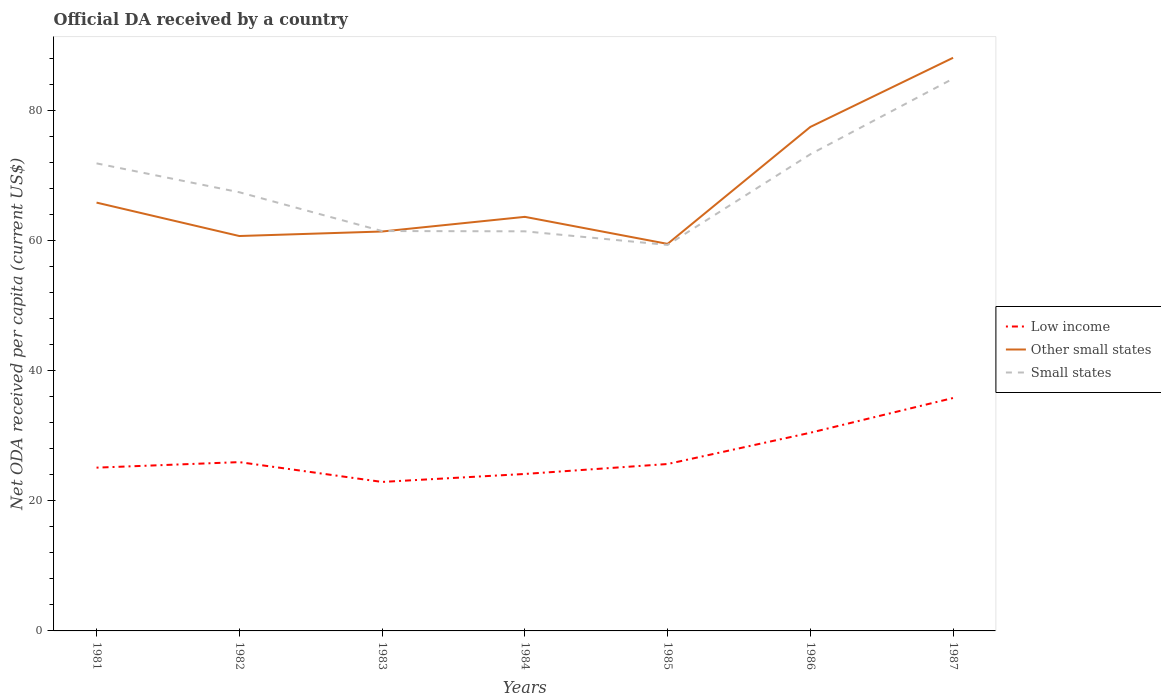Does the line corresponding to Low income intersect with the line corresponding to Other small states?
Your answer should be compact. No. Across all years, what is the maximum ODA received in in Small states?
Provide a succinct answer. 59.34. In which year was the ODA received in in Other small states maximum?
Give a very brief answer. 1985. What is the total ODA received in in Other small states in the graph?
Make the answer very short. -2.95. What is the difference between the highest and the second highest ODA received in in Other small states?
Keep it short and to the point. 28.61. What is the difference between the highest and the lowest ODA received in in Other small states?
Your response must be concise. 2. How many years are there in the graph?
Your response must be concise. 7. Are the values on the major ticks of Y-axis written in scientific E-notation?
Provide a short and direct response. No. How are the legend labels stacked?
Ensure brevity in your answer.  Vertical. What is the title of the graph?
Make the answer very short. Official DA received by a country. What is the label or title of the X-axis?
Provide a short and direct response. Years. What is the label or title of the Y-axis?
Your answer should be very brief. Net ODA received per capita (current US$). What is the Net ODA received per capita (current US$) of Low income in 1981?
Provide a short and direct response. 25.1. What is the Net ODA received per capita (current US$) in Other small states in 1981?
Make the answer very short. 65.85. What is the Net ODA received per capita (current US$) of Small states in 1981?
Your answer should be very brief. 71.88. What is the Net ODA received per capita (current US$) in Low income in 1982?
Offer a very short reply. 25.95. What is the Net ODA received per capita (current US$) of Other small states in 1982?
Provide a short and direct response. 60.71. What is the Net ODA received per capita (current US$) of Small states in 1982?
Make the answer very short. 67.44. What is the Net ODA received per capita (current US$) of Low income in 1983?
Offer a terse response. 22.9. What is the Net ODA received per capita (current US$) of Other small states in 1983?
Give a very brief answer. 61.4. What is the Net ODA received per capita (current US$) in Small states in 1983?
Your answer should be very brief. 61.48. What is the Net ODA received per capita (current US$) in Low income in 1984?
Provide a succinct answer. 24.13. What is the Net ODA received per capita (current US$) of Other small states in 1984?
Provide a short and direct response. 63.66. What is the Net ODA received per capita (current US$) of Small states in 1984?
Give a very brief answer. 61.43. What is the Net ODA received per capita (current US$) in Low income in 1985?
Keep it short and to the point. 25.66. What is the Net ODA received per capita (current US$) in Other small states in 1985?
Provide a succinct answer. 59.5. What is the Net ODA received per capita (current US$) in Small states in 1985?
Provide a short and direct response. 59.34. What is the Net ODA received per capita (current US$) in Low income in 1986?
Provide a succinct answer. 30.47. What is the Net ODA received per capita (current US$) in Other small states in 1986?
Your answer should be very brief. 77.48. What is the Net ODA received per capita (current US$) in Small states in 1986?
Provide a succinct answer. 73.28. What is the Net ODA received per capita (current US$) in Low income in 1987?
Offer a very short reply. 35.81. What is the Net ODA received per capita (current US$) in Other small states in 1987?
Offer a very short reply. 88.11. What is the Net ODA received per capita (current US$) in Small states in 1987?
Give a very brief answer. 84.9. Across all years, what is the maximum Net ODA received per capita (current US$) of Low income?
Keep it short and to the point. 35.81. Across all years, what is the maximum Net ODA received per capita (current US$) in Other small states?
Make the answer very short. 88.11. Across all years, what is the maximum Net ODA received per capita (current US$) of Small states?
Your response must be concise. 84.9. Across all years, what is the minimum Net ODA received per capita (current US$) in Low income?
Your response must be concise. 22.9. Across all years, what is the minimum Net ODA received per capita (current US$) in Other small states?
Your answer should be compact. 59.5. Across all years, what is the minimum Net ODA received per capita (current US$) in Small states?
Your answer should be compact. 59.34. What is the total Net ODA received per capita (current US$) in Low income in the graph?
Your answer should be very brief. 190.02. What is the total Net ODA received per capita (current US$) in Other small states in the graph?
Make the answer very short. 476.71. What is the total Net ODA received per capita (current US$) of Small states in the graph?
Give a very brief answer. 479.75. What is the difference between the Net ODA received per capita (current US$) of Low income in 1981 and that in 1982?
Your answer should be compact. -0.85. What is the difference between the Net ODA received per capita (current US$) of Other small states in 1981 and that in 1982?
Keep it short and to the point. 5.14. What is the difference between the Net ODA received per capita (current US$) in Small states in 1981 and that in 1982?
Ensure brevity in your answer.  4.44. What is the difference between the Net ODA received per capita (current US$) in Low income in 1981 and that in 1983?
Make the answer very short. 2.2. What is the difference between the Net ODA received per capita (current US$) of Other small states in 1981 and that in 1983?
Make the answer very short. 4.44. What is the difference between the Net ODA received per capita (current US$) in Small states in 1981 and that in 1983?
Offer a very short reply. 10.4. What is the difference between the Net ODA received per capita (current US$) of Low income in 1981 and that in 1984?
Your answer should be very brief. 0.97. What is the difference between the Net ODA received per capita (current US$) in Other small states in 1981 and that in 1984?
Keep it short and to the point. 2.19. What is the difference between the Net ODA received per capita (current US$) of Small states in 1981 and that in 1984?
Your response must be concise. 10.45. What is the difference between the Net ODA received per capita (current US$) in Low income in 1981 and that in 1985?
Provide a succinct answer. -0.56. What is the difference between the Net ODA received per capita (current US$) in Other small states in 1981 and that in 1985?
Give a very brief answer. 6.35. What is the difference between the Net ODA received per capita (current US$) in Small states in 1981 and that in 1985?
Offer a very short reply. 12.54. What is the difference between the Net ODA received per capita (current US$) in Low income in 1981 and that in 1986?
Your answer should be very brief. -5.37. What is the difference between the Net ODA received per capita (current US$) of Other small states in 1981 and that in 1986?
Provide a short and direct response. -11.63. What is the difference between the Net ODA received per capita (current US$) of Small states in 1981 and that in 1986?
Provide a succinct answer. -1.4. What is the difference between the Net ODA received per capita (current US$) of Low income in 1981 and that in 1987?
Offer a terse response. -10.71. What is the difference between the Net ODA received per capita (current US$) of Other small states in 1981 and that in 1987?
Offer a terse response. -22.26. What is the difference between the Net ODA received per capita (current US$) of Small states in 1981 and that in 1987?
Ensure brevity in your answer.  -13.02. What is the difference between the Net ODA received per capita (current US$) of Low income in 1982 and that in 1983?
Offer a terse response. 3.05. What is the difference between the Net ODA received per capita (current US$) of Other small states in 1982 and that in 1983?
Offer a very short reply. -0.69. What is the difference between the Net ODA received per capita (current US$) in Small states in 1982 and that in 1983?
Your response must be concise. 5.96. What is the difference between the Net ODA received per capita (current US$) in Low income in 1982 and that in 1984?
Your answer should be very brief. 1.82. What is the difference between the Net ODA received per capita (current US$) of Other small states in 1982 and that in 1984?
Keep it short and to the point. -2.95. What is the difference between the Net ODA received per capita (current US$) in Small states in 1982 and that in 1984?
Your answer should be very brief. 6.01. What is the difference between the Net ODA received per capita (current US$) in Low income in 1982 and that in 1985?
Give a very brief answer. 0.29. What is the difference between the Net ODA received per capita (current US$) in Other small states in 1982 and that in 1985?
Provide a succinct answer. 1.21. What is the difference between the Net ODA received per capita (current US$) in Small states in 1982 and that in 1985?
Give a very brief answer. 8.1. What is the difference between the Net ODA received per capita (current US$) in Low income in 1982 and that in 1986?
Offer a terse response. -4.52. What is the difference between the Net ODA received per capita (current US$) of Other small states in 1982 and that in 1986?
Provide a succinct answer. -16.77. What is the difference between the Net ODA received per capita (current US$) in Small states in 1982 and that in 1986?
Make the answer very short. -5.84. What is the difference between the Net ODA received per capita (current US$) of Low income in 1982 and that in 1987?
Your response must be concise. -9.86. What is the difference between the Net ODA received per capita (current US$) of Other small states in 1982 and that in 1987?
Offer a very short reply. -27.4. What is the difference between the Net ODA received per capita (current US$) of Small states in 1982 and that in 1987?
Give a very brief answer. -17.46. What is the difference between the Net ODA received per capita (current US$) of Low income in 1983 and that in 1984?
Ensure brevity in your answer.  -1.23. What is the difference between the Net ODA received per capita (current US$) of Other small states in 1983 and that in 1984?
Ensure brevity in your answer.  -2.25. What is the difference between the Net ODA received per capita (current US$) of Small states in 1983 and that in 1984?
Your answer should be very brief. 0.04. What is the difference between the Net ODA received per capita (current US$) in Low income in 1983 and that in 1985?
Make the answer very short. -2.75. What is the difference between the Net ODA received per capita (current US$) in Other small states in 1983 and that in 1985?
Your answer should be compact. 1.9. What is the difference between the Net ODA received per capita (current US$) in Small states in 1983 and that in 1985?
Provide a short and direct response. 2.13. What is the difference between the Net ODA received per capita (current US$) in Low income in 1983 and that in 1986?
Provide a succinct answer. -7.56. What is the difference between the Net ODA received per capita (current US$) in Other small states in 1983 and that in 1986?
Your answer should be very brief. -16.07. What is the difference between the Net ODA received per capita (current US$) of Small states in 1983 and that in 1986?
Your response must be concise. -11.8. What is the difference between the Net ODA received per capita (current US$) of Low income in 1983 and that in 1987?
Give a very brief answer. -12.9. What is the difference between the Net ODA received per capita (current US$) in Other small states in 1983 and that in 1987?
Make the answer very short. -26.71. What is the difference between the Net ODA received per capita (current US$) in Small states in 1983 and that in 1987?
Give a very brief answer. -23.43. What is the difference between the Net ODA received per capita (current US$) in Low income in 1984 and that in 1985?
Give a very brief answer. -1.53. What is the difference between the Net ODA received per capita (current US$) of Other small states in 1984 and that in 1985?
Ensure brevity in your answer.  4.16. What is the difference between the Net ODA received per capita (current US$) in Small states in 1984 and that in 1985?
Your answer should be very brief. 2.09. What is the difference between the Net ODA received per capita (current US$) in Low income in 1984 and that in 1986?
Keep it short and to the point. -6.34. What is the difference between the Net ODA received per capita (current US$) of Other small states in 1984 and that in 1986?
Your answer should be compact. -13.82. What is the difference between the Net ODA received per capita (current US$) of Small states in 1984 and that in 1986?
Give a very brief answer. -11.85. What is the difference between the Net ODA received per capita (current US$) of Low income in 1984 and that in 1987?
Ensure brevity in your answer.  -11.68. What is the difference between the Net ODA received per capita (current US$) of Other small states in 1984 and that in 1987?
Your answer should be compact. -24.45. What is the difference between the Net ODA received per capita (current US$) of Small states in 1984 and that in 1987?
Your response must be concise. -23.47. What is the difference between the Net ODA received per capita (current US$) of Low income in 1985 and that in 1986?
Your answer should be very brief. -4.81. What is the difference between the Net ODA received per capita (current US$) of Other small states in 1985 and that in 1986?
Keep it short and to the point. -17.98. What is the difference between the Net ODA received per capita (current US$) of Small states in 1985 and that in 1986?
Keep it short and to the point. -13.94. What is the difference between the Net ODA received per capita (current US$) in Low income in 1985 and that in 1987?
Give a very brief answer. -10.15. What is the difference between the Net ODA received per capita (current US$) in Other small states in 1985 and that in 1987?
Your answer should be very brief. -28.61. What is the difference between the Net ODA received per capita (current US$) in Small states in 1985 and that in 1987?
Offer a very short reply. -25.56. What is the difference between the Net ODA received per capita (current US$) of Low income in 1986 and that in 1987?
Ensure brevity in your answer.  -5.34. What is the difference between the Net ODA received per capita (current US$) in Other small states in 1986 and that in 1987?
Your response must be concise. -10.63. What is the difference between the Net ODA received per capita (current US$) of Small states in 1986 and that in 1987?
Your response must be concise. -11.62. What is the difference between the Net ODA received per capita (current US$) in Low income in 1981 and the Net ODA received per capita (current US$) in Other small states in 1982?
Your response must be concise. -35.61. What is the difference between the Net ODA received per capita (current US$) of Low income in 1981 and the Net ODA received per capita (current US$) of Small states in 1982?
Provide a short and direct response. -42.34. What is the difference between the Net ODA received per capita (current US$) in Other small states in 1981 and the Net ODA received per capita (current US$) in Small states in 1982?
Keep it short and to the point. -1.59. What is the difference between the Net ODA received per capita (current US$) of Low income in 1981 and the Net ODA received per capita (current US$) of Other small states in 1983?
Your answer should be compact. -36.3. What is the difference between the Net ODA received per capita (current US$) of Low income in 1981 and the Net ODA received per capita (current US$) of Small states in 1983?
Your answer should be compact. -36.37. What is the difference between the Net ODA received per capita (current US$) in Other small states in 1981 and the Net ODA received per capita (current US$) in Small states in 1983?
Ensure brevity in your answer.  4.37. What is the difference between the Net ODA received per capita (current US$) in Low income in 1981 and the Net ODA received per capita (current US$) in Other small states in 1984?
Offer a very short reply. -38.56. What is the difference between the Net ODA received per capita (current US$) of Low income in 1981 and the Net ODA received per capita (current US$) of Small states in 1984?
Offer a very short reply. -36.33. What is the difference between the Net ODA received per capita (current US$) of Other small states in 1981 and the Net ODA received per capita (current US$) of Small states in 1984?
Your answer should be very brief. 4.41. What is the difference between the Net ODA received per capita (current US$) in Low income in 1981 and the Net ODA received per capita (current US$) in Other small states in 1985?
Give a very brief answer. -34.4. What is the difference between the Net ODA received per capita (current US$) of Low income in 1981 and the Net ODA received per capita (current US$) of Small states in 1985?
Make the answer very short. -34.24. What is the difference between the Net ODA received per capita (current US$) in Other small states in 1981 and the Net ODA received per capita (current US$) in Small states in 1985?
Your answer should be very brief. 6.51. What is the difference between the Net ODA received per capita (current US$) in Low income in 1981 and the Net ODA received per capita (current US$) in Other small states in 1986?
Give a very brief answer. -52.38. What is the difference between the Net ODA received per capita (current US$) of Low income in 1981 and the Net ODA received per capita (current US$) of Small states in 1986?
Give a very brief answer. -48.18. What is the difference between the Net ODA received per capita (current US$) in Other small states in 1981 and the Net ODA received per capita (current US$) in Small states in 1986?
Provide a succinct answer. -7.43. What is the difference between the Net ODA received per capita (current US$) in Low income in 1981 and the Net ODA received per capita (current US$) in Other small states in 1987?
Your answer should be very brief. -63.01. What is the difference between the Net ODA received per capita (current US$) in Low income in 1981 and the Net ODA received per capita (current US$) in Small states in 1987?
Your answer should be compact. -59.8. What is the difference between the Net ODA received per capita (current US$) in Other small states in 1981 and the Net ODA received per capita (current US$) in Small states in 1987?
Ensure brevity in your answer.  -19.05. What is the difference between the Net ODA received per capita (current US$) of Low income in 1982 and the Net ODA received per capita (current US$) of Other small states in 1983?
Give a very brief answer. -35.45. What is the difference between the Net ODA received per capita (current US$) in Low income in 1982 and the Net ODA received per capita (current US$) in Small states in 1983?
Offer a terse response. -35.52. What is the difference between the Net ODA received per capita (current US$) in Other small states in 1982 and the Net ODA received per capita (current US$) in Small states in 1983?
Give a very brief answer. -0.77. What is the difference between the Net ODA received per capita (current US$) in Low income in 1982 and the Net ODA received per capita (current US$) in Other small states in 1984?
Keep it short and to the point. -37.71. What is the difference between the Net ODA received per capita (current US$) in Low income in 1982 and the Net ODA received per capita (current US$) in Small states in 1984?
Give a very brief answer. -35.48. What is the difference between the Net ODA received per capita (current US$) of Other small states in 1982 and the Net ODA received per capita (current US$) of Small states in 1984?
Offer a very short reply. -0.72. What is the difference between the Net ODA received per capita (current US$) of Low income in 1982 and the Net ODA received per capita (current US$) of Other small states in 1985?
Your answer should be compact. -33.55. What is the difference between the Net ODA received per capita (current US$) in Low income in 1982 and the Net ODA received per capita (current US$) in Small states in 1985?
Offer a very short reply. -33.39. What is the difference between the Net ODA received per capita (current US$) of Other small states in 1982 and the Net ODA received per capita (current US$) of Small states in 1985?
Ensure brevity in your answer.  1.37. What is the difference between the Net ODA received per capita (current US$) of Low income in 1982 and the Net ODA received per capita (current US$) of Other small states in 1986?
Offer a very short reply. -51.53. What is the difference between the Net ODA received per capita (current US$) of Low income in 1982 and the Net ODA received per capita (current US$) of Small states in 1986?
Make the answer very short. -47.33. What is the difference between the Net ODA received per capita (current US$) in Other small states in 1982 and the Net ODA received per capita (current US$) in Small states in 1986?
Your response must be concise. -12.57. What is the difference between the Net ODA received per capita (current US$) in Low income in 1982 and the Net ODA received per capita (current US$) in Other small states in 1987?
Your answer should be very brief. -62.16. What is the difference between the Net ODA received per capita (current US$) in Low income in 1982 and the Net ODA received per capita (current US$) in Small states in 1987?
Provide a short and direct response. -58.95. What is the difference between the Net ODA received per capita (current US$) in Other small states in 1982 and the Net ODA received per capita (current US$) in Small states in 1987?
Give a very brief answer. -24.19. What is the difference between the Net ODA received per capita (current US$) in Low income in 1983 and the Net ODA received per capita (current US$) in Other small states in 1984?
Make the answer very short. -40.75. What is the difference between the Net ODA received per capita (current US$) of Low income in 1983 and the Net ODA received per capita (current US$) of Small states in 1984?
Offer a terse response. -38.53. What is the difference between the Net ODA received per capita (current US$) of Other small states in 1983 and the Net ODA received per capita (current US$) of Small states in 1984?
Your answer should be very brief. -0.03. What is the difference between the Net ODA received per capita (current US$) in Low income in 1983 and the Net ODA received per capita (current US$) in Other small states in 1985?
Give a very brief answer. -36.6. What is the difference between the Net ODA received per capita (current US$) of Low income in 1983 and the Net ODA received per capita (current US$) of Small states in 1985?
Your response must be concise. -36.44. What is the difference between the Net ODA received per capita (current US$) in Other small states in 1983 and the Net ODA received per capita (current US$) in Small states in 1985?
Your response must be concise. 2.06. What is the difference between the Net ODA received per capita (current US$) of Low income in 1983 and the Net ODA received per capita (current US$) of Other small states in 1986?
Give a very brief answer. -54.58. What is the difference between the Net ODA received per capita (current US$) in Low income in 1983 and the Net ODA received per capita (current US$) in Small states in 1986?
Offer a terse response. -50.37. What is the difference between the Net ODA received per capita (current US$) of Other small states in 1983 and the Net ODA received per capita (current US$) of Small states in 1986?
Ensure brevity in your answer.  -11.87. What is the difference between the Net ODA received per capita (current US$) in Low income in 1983 and the Net ODA received per capita (current US$) in Other small states in 1987?
Provide a succinct answer. -65.21. What is the difference between the Net ODA received per capita (current US$) in Low income in 1983 and the Net ODA received per capita (current US$) in Small states in 1987?
Your answer should be very brief. -62. What is the difference between the Net ODA received per capita (current US$) in Other small states in 1983 and the Net ODA received per capita (current US$) in Small states in 1987?
Make the answer very short. -23.5. What is the difference between the Net ODA received per capita (current US$) in Low income in 1984 and the Net ODA received per capita (current US$) in Other small states in 1985?
Provide a short and direct response. -35.37. What is the difference between the Net ODA received per capita (current US$) in Low income in 1984 and the Net ODA received per capita (current US$) in Small states in 1985?
Your answer should be very brief. -35.21. What is the difference between the Net ODA received per capita (current US$) of Other small states in 1984 and the Net ODA received per capita (current US$) of Small states in 1985?
Provide a succinct answer. 4.32. What is the difference between the Net ODA received per capita (current US$) of Low income in 1984 and the Net ODA received per capita (current US$) of Other small states in 1986?
Offer a terse response. -53.35. What is the difference between the Net ODA received per capita (current US$) in Low income in 1984 and the Net ODA received per capita (current US$) in Small states in 1986?
Offer a terse response. -49.15. What is the difference between the Net ODA received per capita (current US$) in Other small states in 1984 and the Net ODA received per capita (current US$) in Small states in 1986?
Your response must be concise. -9.62. What is the difference between the Net ODA received per capita (current US$) of Low income in 1984 and the Net ODA received per capita (current US$) of Other small states in 1987?
Provide a succinct answer. -63.98. What is the difference between the Net ODA received per capita (current US$) of Low income in 1984 and the Net ODA received per capita (current US$) of Small states in 1987?
Your response must be concise. -60.77. What is the difference between the Net ODA received per capita (current US$) in Other small states in 1984 and the Net ODA received per capita (current US$) in Small states in 1987?
Your response must be concise. -21.24. What is the difference between the Net ODA received per capita (current US$) of Low income in 1985 and the Net ODA received per capita (current US$) of Other small states in 1986?
Your response must be concise. -51.82. What is the difference between the Net ODA received per capita (current US$) in Low income in 1985 and the Net ODA received per capita (current US$) in Small states in 1986?
Keep it short and to the point. -47.62. What is the difference between the Net ODA received per capita (current US$) in Other small states in 1985 and the Net ODA received per capita (current US$) in Small states in 1986?
Your response must be concise. -13.78. What is the difference between the Net ODA received per capita (current US$) of Low income in 1985 and the Net ODA received per capita (current US$) of Other small states in 1987?
Give a very brief answer. -62.45. What is the difference between the Net ODA received per capita (current US$) in Low income in 1985 and the Net ODA received per capita (current US$) in Small states in 1987?
Keep it short and to the point. -59.24. What is the difference between the Net ODA received per capita (current US$) in Other small states in 1985 and the Net ODA received per capita (current US$) in Small states in 1987?
Your response must be concise. -25.4. What is the difference between the Net ODA received per capita (current US$) in Low income in 1986 and the Net ODA received per capita (current US$) in Other small states in 1987?
Offer a very short reply. -57.64. What is the difference between the Net ODA received per capita (current US$) of Low income in 1986 and the Net ODA received per capita (current US$) of Small states in 1987?
Provide a short and direct response. -54.43. What is the difference between the Net ODA received per capita (current US$) of Other small states in 1986 and the Net ODA received per capita (current US$) of Small states in 1987?
Ensure brevity in your answer.  -7.42. What is the average Net ODA received per capita (current US$) of Low income per year?
Offer a terse response. 27.15. What is the average Net ODA received per capita (current US$) in Other small states per year?
Offer a very short reply. 68.1. What is the average Net ODA received per capita (current US$) of Small states per year?
Your answer should be compact. 68.54. In the year 1981, what is the difference between the Net ODA received per capita (current US$) of Low income and Net ODA received per capita (current US$) of Other small states?
Offer a terse response. -40.75. In the year 1981, what is the difference between the Net ODA received per capita (current US$) in Low income and Net ODA received per capita (current US$) in Small states?
Ensure brevity in your answer.  -46.78. In the year 1981, what is the difference between the Net ODA received per capita (current US$) of Other small states and Net ODA received per capita (current US$) of Small states?
Provide a succinct answer. -6.03. In the year 1982, what is the difference between the Net ODA received per capita (current US$) in Low income and Net ODA received per capita (current US$) in Other small states?
Offer a terse response. -34.76. In the year 1982, what is the difference between the Net ODA received per capita (current US$) of Low income and Net ODA received per capita (current US$) of Small states?
Your response must be concise. -41.49. In the year 1982, what is the difference between the Net ODA received per capita (current US$) of Other small states and Net ODA received per capita (current US$) of Small states?
Give a very brief answer. -6.73. In the year 1983, what is the difference between the Net ODA received per capita (current US$) in Low income and Net ODA received per capita (current US$) in Other small states?
Provide a succinct answer. -38.5. In the year 1983, what is the difference between the Net ODA received per capita (current US$) of Low income and Net ODA received per capita (current US$) of Small states?
Your answer should be compact. -38.57. In the year 1983, what is the difference between the Net ODA received per capita (current US$) of Other small states and Net ODA received per capita (current US$) of Small states?
Keep it short and to the point. -0.07. In the year 1984, what is the difference between the Net ODA received per capita (current US$) of Low income and Net ODA received per capita (current US$) of Other small states?
Offer a very short reply. -39.53. In the year 1984, what is the difference between the Net ODA received per capita (current US$) of Low income and Net ODA received per capita (current US$) of Small states?
Your response must be concise. -37.3. In the year 1984, what is the difference between the Net ODA received per capita (current US$) of Other small states and Net ODA received per capita (current US$) of Small states?
Your answer should be very brief. 2.22. In the year 1985, what is the difference between the Net ODA received per capita (current US$) in Low income and Net ODA received per capita (current US$) in Other small states?
Ensure brevity in your answer.  -33.84. In the year 1985, what is the difference between the Net ODA received per capita (current US$) of Low income and Net ODA received per capita (current US$) of Small states?
Keep it short and to the point. -33.68. In the year 1985, what is the difference between the Net ODA received per capita (current US$) in Other small states and Net ODA received per capita (current US$) in Small states?
Offer a very short reply. 0.16. In the year 1986, what is the difference between the Net ODA received per capita (current US$) in Low income and Net ODA received per capita (current US$) in Other small states?
Provide a short and direct response. -47.01. In the year 1986, what is the difference between the Net ODA received per capita (current US$) in Low income and Net ODA received per capita (current US$) in Small states?
Offer a terse response. -42.81. In the year 1986, what is the difference between the Net ODA received per capita (current US$) in Other small states and Net ODA received per capita (current US$) in Small states?
Offer a terse response. 4.2. In the year 1987, what is the difference between the Net ODA received per capita (current US$) of Low income and Net ODA received per capita (current US$) of Other small states?
Offer a terse response. -52.3. In the year 1987, what is the difference between the Net ODA received per capita (current US$) in Low income and Net ODA received per capita (current US$) in Small states?
Offer a very short reply. -49.09. In the year 1987, what is the difference between the Net ODA received per capita (current US$) in Other small states and Net ODA received per capita (current US$) in Small states?
Make the answer very short. 3.21. What is the ratio of the Net ODA received per capita (current US$) of Low income in 1981 to that in 1982?
Your response must be concise. 0.97. What is the ratio of the Net ODA received per capita (current US$) of Other small states in 1981 to that in 1982?
Offer a very short reply. 1.08. What is the ratio of the Net ODA received per capita (current US$) in Small states in 1981 to that in 1982?
Offer a terse response. 1.07. What is the ratio of the Net ODA received per capita (current US$) in Low income in 1981 to that in 1983?
Your answer should be compact. 1.1. What is the ratio of the Net ODA received per capita (current US$) in Other small states in 1981 to that in 1983?
Your answer should be compact. 1.07. What is the ratio of the Net ODA received per capita (current US$) of Small states in 1981 to that in 1983?
Ensure brevity in your answer.  1.17. What is the ratio of the Net ODA received per capita (current US$) of Low income in 1981 to that in 1984?
Make the answer very short. 1.04. What is the ratio of the Net ODA received per capita (current US$) of Other small states in 1981 to that in 1984?
Your answer should be very brief. 1.03. What is the ratio of the Net ODA received per capita (current US$) in Small states in 1981 to that in 1984?
Your answer should be compact. 1.17. What is the ratio of the Net ODA received per capita (current US$) of Low income in 1981 to that in 1985?
Your answer should be very brief. 0.98. What is the ratio of the Net ODA received per capita (current US$) in Other small states in 1981 to that in 1985?
Your answer should be compact. 1.11. What is the ratio of the Net ODA received per capita (current US$) in Small states in 1981 to that in 1985?
Provide a short and direct response. 1.21. What is the ratio of the Net ODA received per capita (current US$) in Low income in 1981 to that in 1986?
Give a very brief answer. 0.82. What is the ratio of the Net ODA received per capita (current US$) in Other small states in 1981 to that in 1986?
Your response must be concise. 0.85. What is the ratio of the Net ODA received per capita (current US$) of Small states in 1981 to that in 1986?
Ensure brevity in your answer.  0.98. What is the ratio of the Net ODA received per capita (current US$) of Low income in 1981 to that in 1987?
Offer a very short reply. 0.7. What is the ratio of the Net ODA received per capita (current US$) of Other small states in 1981 to that in 1987?
Keep it short and to the point. 0.75. What is the ratio of the Net ODA received per capita (current US$) in Small states in 1981 to that in 1987?
Your answer should be compact. 0.85. What is the ratio of the Net ODA received per capita (current US$) in Low income in 1982 to that in 1983?
Provide a short and direct response. 1.13. What is the ratio of the Net ODA received per capita (current US$) in Other small states in 1982 to that in 1983?
Offer a very short reply. 0.99. What is the ratio of the Net ODA received per capita (current US$) of Small states in 1982 to that in 1983?
Your answer should be very brief. 1.1. What is the ratio of the Net ODA received per capita (current US$) of Low income in 1982 to that in 1984?
Offer a terse response. 1.08. What is the ratio of the Net ODA received per capita (current US$) of Other small states in 1982 to that in 1984?
Provide a succinct answer. 0.95. What is the ratio of the Net ODA received per capita (current US$) of Small states in 1982 to that in 1984?
Make the answer very short. 1.1. What is the ratio of the Net ODA received per capita (current US$) of Low income in 1982 to that in 1985?
Your answer should be compact. 1.01. What is the ratio of the Net ODA received per capita (current US$) in Other small states in 1982 to that in 1985?
Offer a terse response. 1.02. What is the ratio of the Net ODA received per capita (current US$) in Small states in 1982 to that in 1985?
Your answer should be very brief. 1.14. What is the ratio of the Net ODA received per capita (current US$) in Low income in 1982 to that in 1986?
Offer a terse response. 0.85. What is the ratio of the Net ODA received per capita (current US$) in Other small states in 1982 to that in 1986?
Make the answer very short. 0.78. What is the ratio of the Net ODA received per capita (current US$) of Small states in 1982 to that in 1986?
Your response must be concise. 0.92. What is the ratio of the Net ODA received per capita (current US$) of Low income in 1982 to that in 1987?
Make the answer very short. 0.72. What is the ratio of the Net ODA received per capita (current US$) in Other small states in 1982 to that in 1987?
Offer a very short reply. 0.69. What is the ratio of the Net ODA received per capita (current US$) in Small states in 1982 to that in 1987?
Give a very brief answer. 0.79. What is the ratio of the Net ODA received per capita (current US$) of Low income in 1983 to that in 1984?
Ensure brevity in your answer.  0.95. What is the ratio of the Net ODA received per capita (current US$) of Other small states in 1983 to that in 1984?
Your answer should be compact. 0.96. What is the ratio of the Net ODA received per capita (current US$) in Small states in 1983 to that in 1984?
Your answer should be very brief. 1. What is the ratio of the Net ODA received per capita (current US$) of Low income in 1983 to that in 1985?
Your response must be concise. 0.89. What is the ratio of the Net ODA received per capita (current US$) of Other small states in 1983 to that in 1985?
Give a very brief answer. 1.03. What is the ratio of the Net ODA received per capita (current US$) in Small states in 1983 to that in 1985?
Ensure brevity in your answer.  1.04. What is the ratio of the Net ODA received per capita (current US$) in Low income in 1983 to that in 1986?
Offer a terse response. 0.75. What is the ratio of the Net ODA received per capita (current US$) in Other small states in 1983 to that in 1986?
Ensure brevity in your answer.  0.79. What is the ratio of the Net ODA received per capita (current US$) of Small states in 1983 to that in 1986?
Offer a terse response. 0.84. What is the ratio of the Net ODA received per capita (current US$) in Low income in 1983 to that in 1987?
Provide a short and direct response. 0.64. What is the ratio of the Net ODA received per capita (current US$) of Other small states in 1983 to that in 1987?
Provide a succinct answer. 0.7. What is the ratio of the Net ODA received per capita (current US$) of Small states in 1983 to that in 1987?
Offer a terse response. 0.72. What is the ratio of the Net ODA received per capita (current US$) of Low income in 1984 to that in 1985?
Ensure brevity in your answer.  0.94. What is the ratio of the Net ODA received per capita (current US$) of Other small states in 1984 to that in 1985?
Your answer should be compact. 1.07. What is the ratio of the Net ODA received per capita (current US$) of Small states in 1984 to that in 1985?
Your answer should be compact. 1.04. What is the ratio of the Net ODA received per capita (current US$) of Low income in 1984 to that in 1986?
Provide a short and direct response. 0.79. What is the ratio of the Net ODA received per capita (current US$) in Other small states in 1984 to that in 1986?
Offer a very short reply. 0.82. What is the ratio of the Net ODA received per capita (current US$) of Small states in 1984 to that in 1986?
Your answer should be very brief. 0.84. What is the ratio of the Net ODA received per capita (current US$) of Low income in 1984 to that in 1987?
Make the answer very short. 0.67. What is the ratio of the Net ODA received per capita (current US$) of Other small states in 1984 to that in 1987?
Keep it short and to the point. 0.72. What is the ratio of the Net ODA received per capita (current US$) of Small states in 1984 to that in 1987?
Offer a terse response. 0.72. What is the ratio of the Net ODA received per capita (current US$) of Low income in 1985 to that in 1986?
Provide a succinct answer. 0.84. What is the ratio of the Net ODA received per capita (current US$) in Other small states in 1985 to that in 1986?
Provide a succinct answer. 0.77. What is the ratio of the Net ODA received per capita (current US$) of Small states in 1985 to that in 1986?
Your answer should be very brief. 0.81. What is the ratio of the Net ODA received per capita (current US$) of Low income in 1985 to that in 1987?
Your answer should be very brief. 0.72. What is the ratio of the Net ODA received per capita (current US$) of Other small states in 1985 to that in 1987?
Your answer should be very brief. 0.68. What is the ratio of the Net ODA received per capita (current US$) in Small states in 1985 to that in 1987?
Provide a short and direct response. 0.7. What is the ratio of the Net ODA received per capita (current US$) in Low income in 1986 to that in 1987?
Give a very brief answer. 0.85. What is the ratio of the Net ODA received per capita (current US$) in Other small states in 1986 to that in 1987?
Offer a terse response. 0.88. What is the ratio of the Net ODA received per capita (current US$) of Small states in 1986 to that in 1987?
Your answer should be very brief. 0.86. What is the difference between the highest and the second highest Net ODA received per capita (current US$) in Low income?
Keep it short and to the point. 5.34. What is the difference between the highest and the second highest Net ODA received per capita (current US$) in Other small states?
Ensure brevity in your answer.  10.63. What is the difference between the highest and the second highest Net ODA received per capita (current US$) of Small states?
Provide a short and direct response. 11.62. What is the difference between the highest and the lowest Net ODA received per capita (current US$) of Low income?
Your answer should be compact. 12.9. What is the difference between the highest and the lowest Net ODA received per capita (current US$) of Other small states?
Ensure brevity in your answer.  28.61. What is the difference between the highest and the lowest Net ODA received per capita (current US$) of Small states?
Your response must be concise. 25.56. 